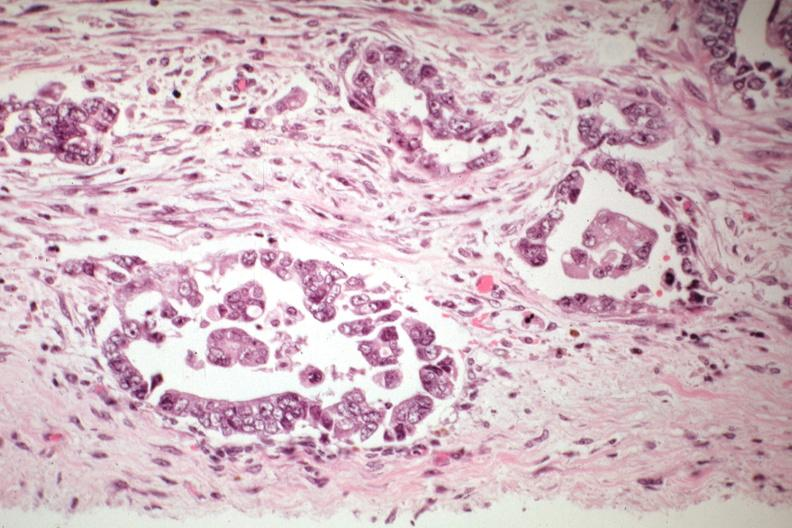s mixed mesodermal tumor present?
Answer the question using a single word or phrase. Yes 